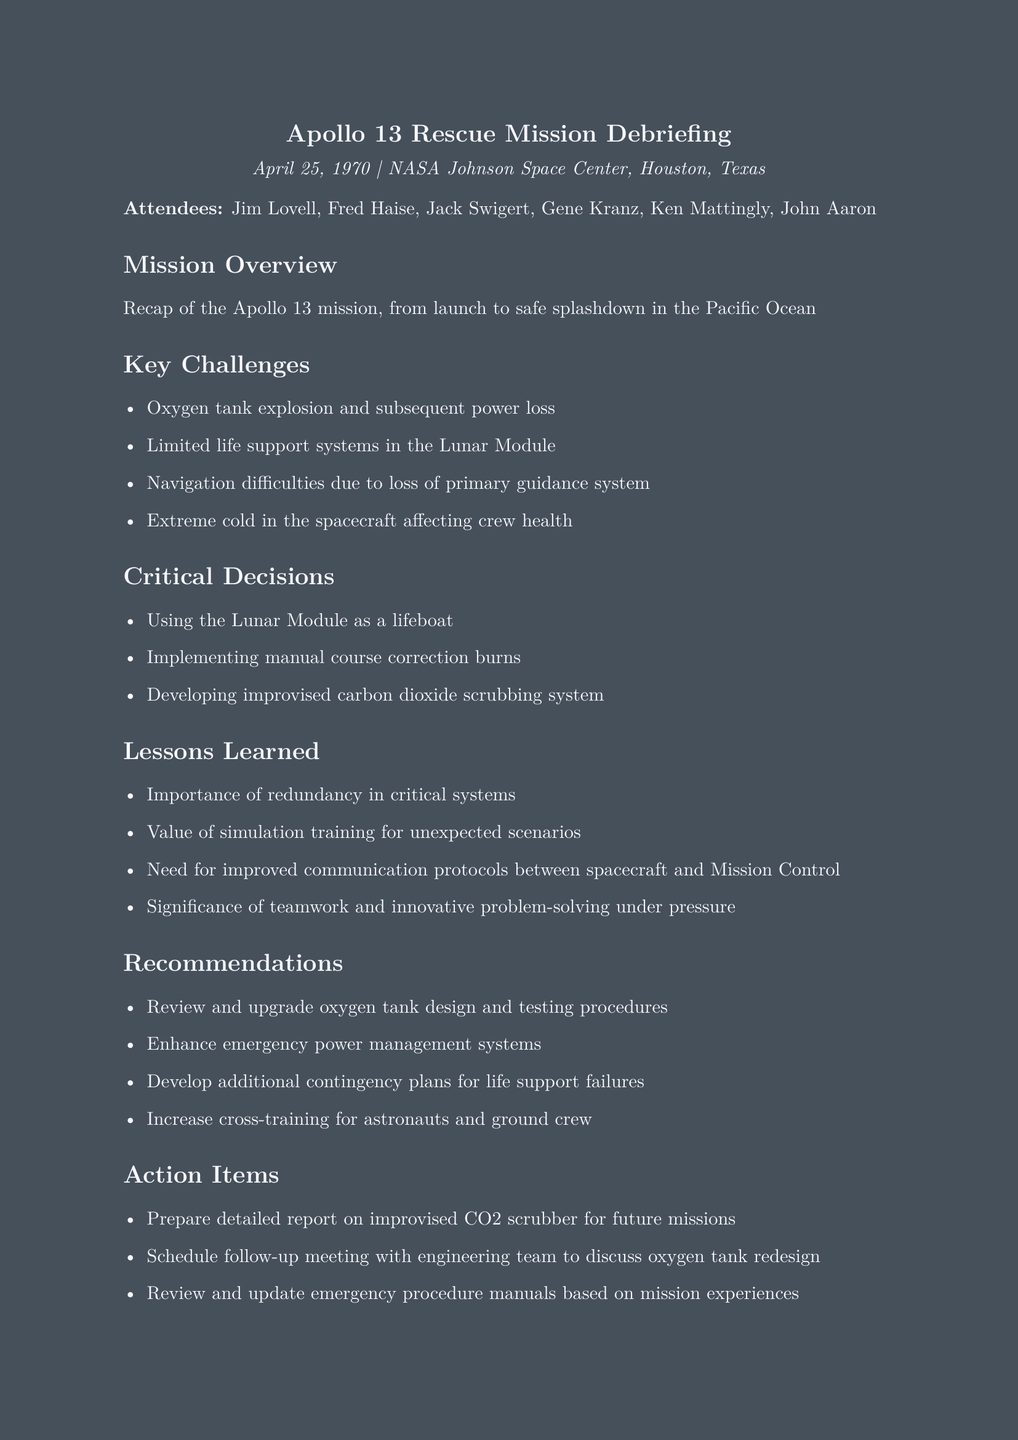What is the date of the meeting? The date of the meeting is specified in the document header.
Answer: April 25, 1970 Who was the first attendee listed? The first attendee is the person mentioned at the beginning of the attendees list.
Answer: Jim Lovell What was one of the key challenges faced during the mission? One of the challenges is mentioned in the "Key Challenges" section.
Answer: Oxygen tank explosion and subsequent power loss What critical decision was made regarding the Lunar Module? The decision is referenced in the "Critical Decisions" section.
Answer: Using the Lunar Module as a lifeboat What is one lesson learned from the mission? The lessons learned are outlined in the "Lessons Learned" section.
Answer: Importance of redundancy in critical systems How many action items were listed in the document? The action items are specified in the "Action Items" section.
Answer: Three What was one recommendation for future missions? Recommendations are provided in the "Recommendations" section.
Answer: Review and upgrade oxygen tank design and testing procedures Who was responsible for scheduling the follow-up meeting? The action items indicate who will be responsible for the follow-up.
Answer: Not specified (action item is general) What was the location of the meeting? The location is stated in the document header.
Answer: NASA Johnson Space Center, Houston, Texas 